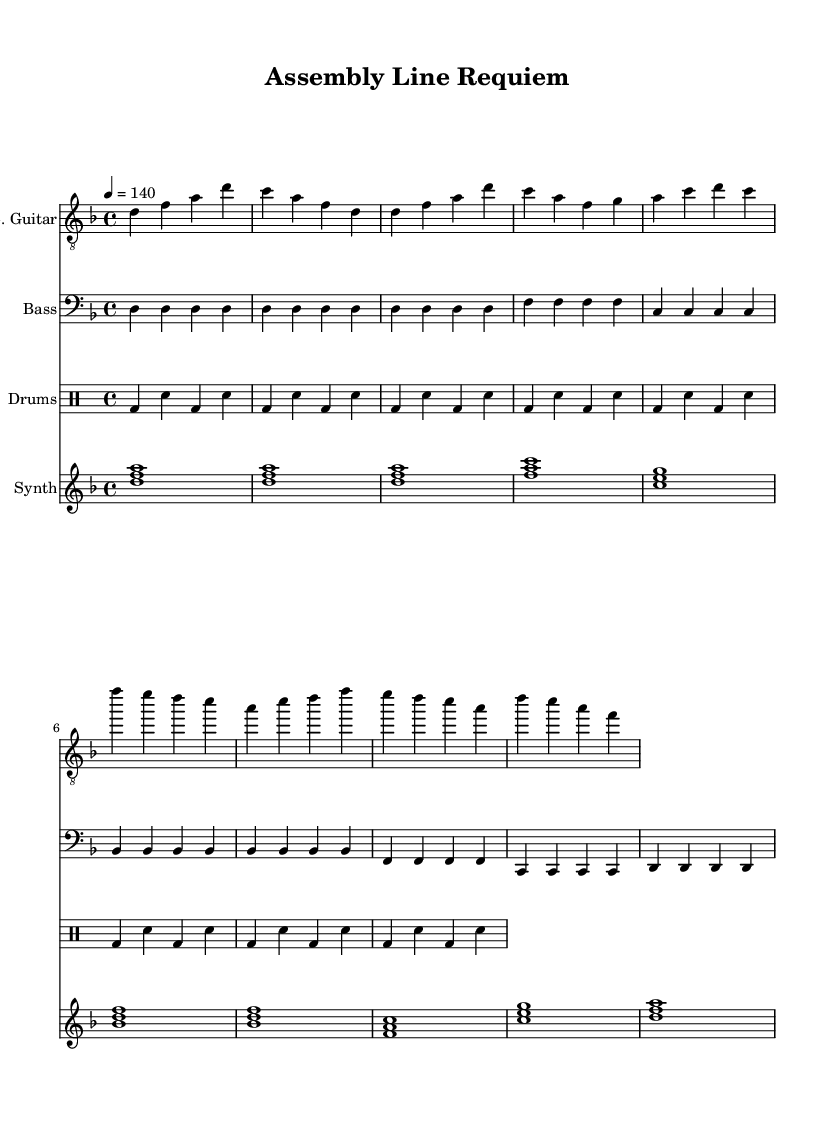What is the key signature of this music? The key signature is D minor, which has one flat (B flat). It is indicated at the beginning of the score just after the clef symbol.
Answer: D minor What is the time signature of this music? The time signature is 4/4, meaning there are four beats in each measure and a quarter note receives one beat. This can be found at the beginning of the score.
Answer: 4/4 What is the tempo marking for this piece? The tempo marking is 4 equals 140, which indicates the speed of the piece, with a quarter note getting 140 beats per minute. This is located in the tempo section right after the time signature.
Answer: 140 How many measures are in the introduction section? The introduction section consists of 2 measures, which can be identified by counting the measures from the beginning marked by the initial note patterns for the electric guitar.
Answer: 2 Which instrument plays the main melodic riff? The electric guitar plays the main melodic riff as recognized by its distinctive part written in the treble clef with the corresponding rhythms in the score.
Answer: Electric Guitar What rhythmic pattern is predominantly used in the drum part? The predominant rhythm pattern in the drum part is a basic rock beat featuring a kick on the first and third beats and snares on the second and fourth beats, observable throughout the drum measures.
Answer: Basic rock beat How does the synthesizer contribute to the overall texture of the song? The synthesizer creates ambient layers and harmonic support with sustained chords that complement the other instruments, enhancing the overall sound texture of the piece. This can be inferred from its consistent chord progression throughout the score.
Answer: Ambient layers 